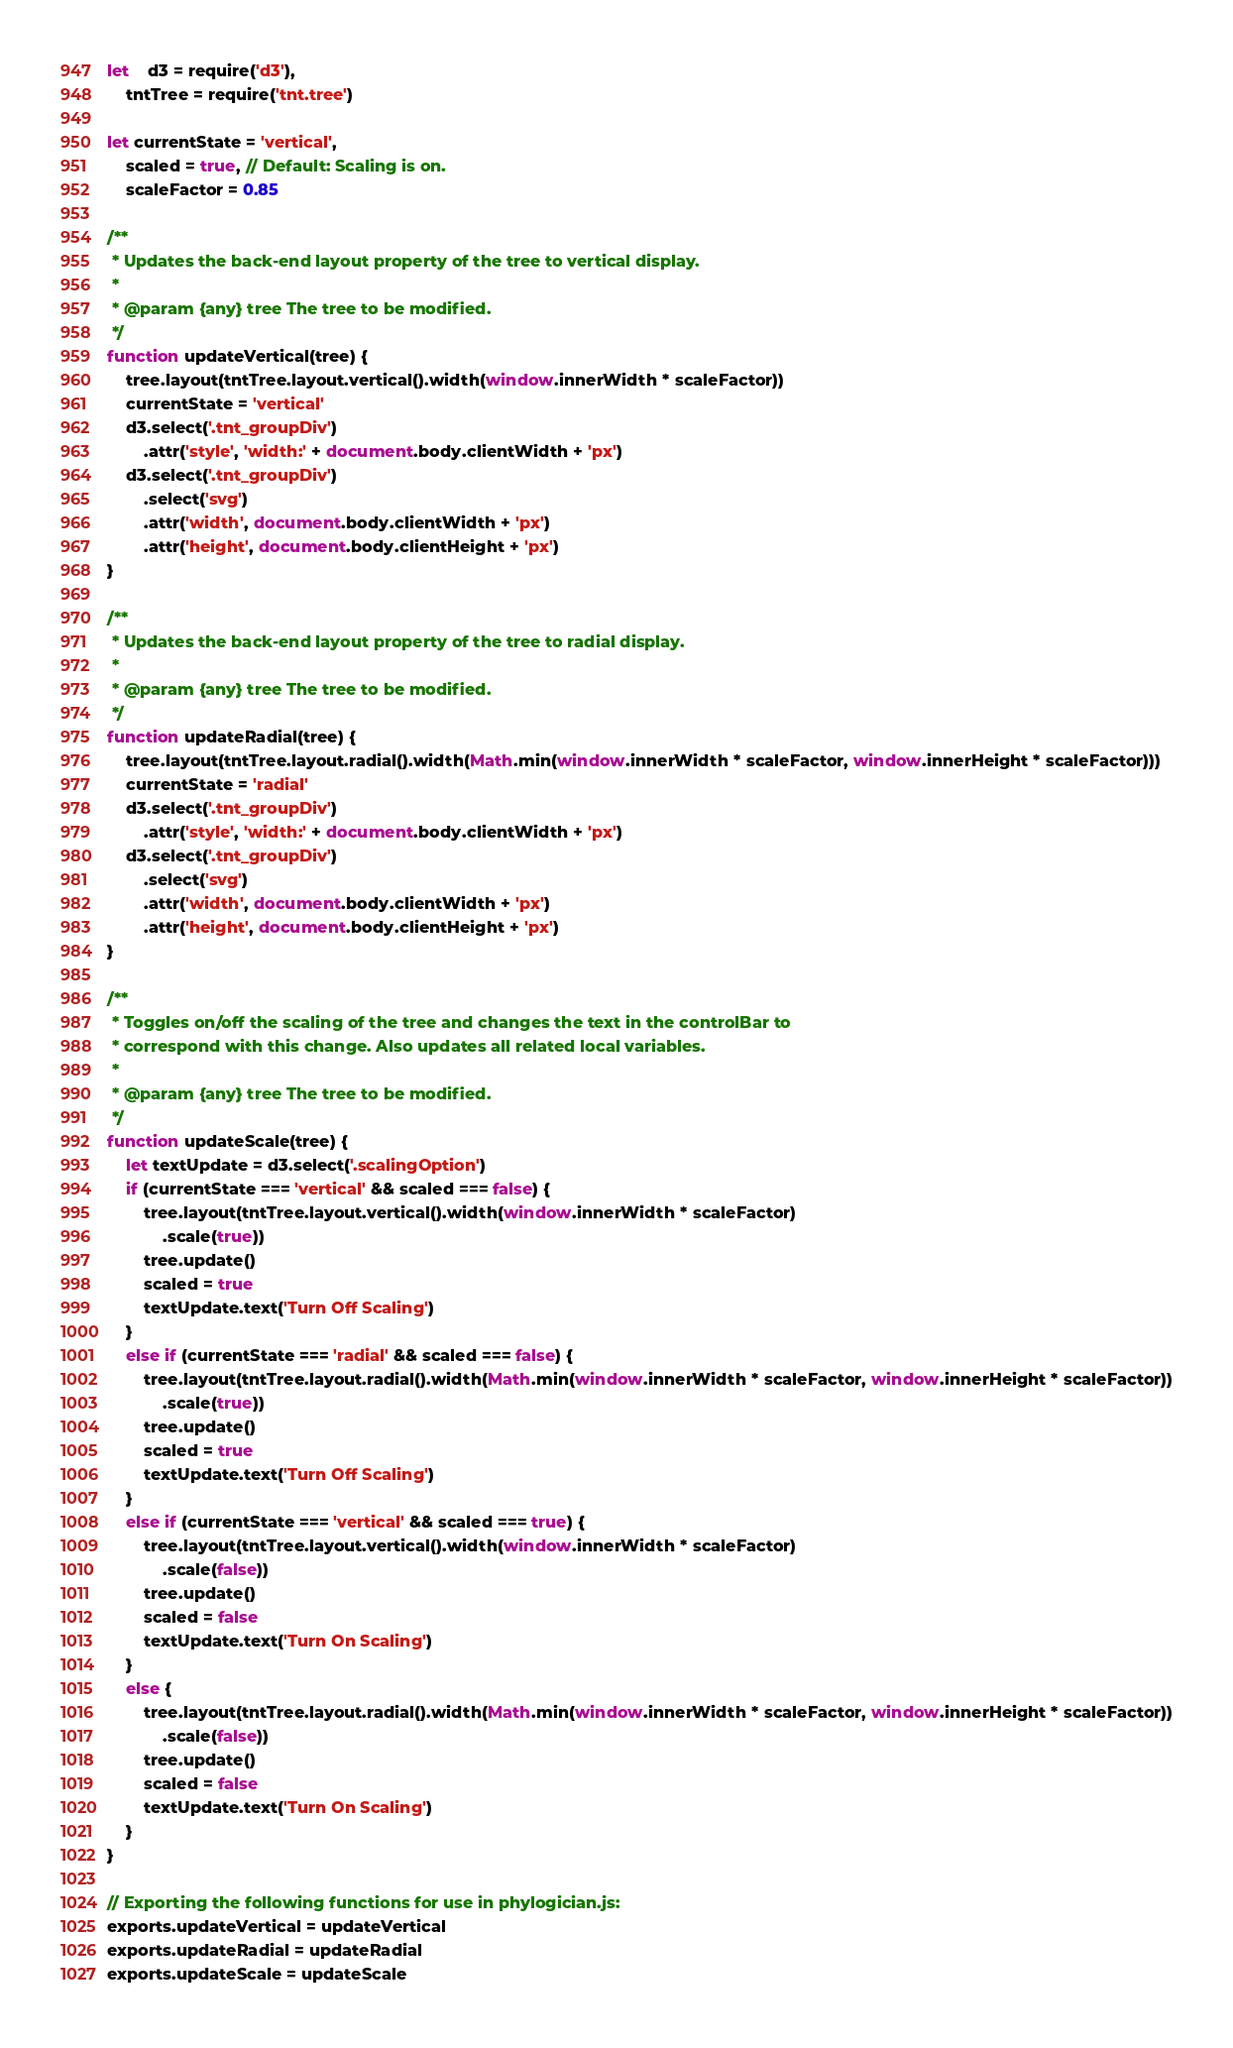<code> <loc_0><loc_0><loc_500><loc_500><_JavaScript_>
let	d3 = require('d3'),
	tntTree = require('tnt.tree')

let currentState = 'vertical',
	scaled = true, // Default: Scaling is on.
	scaleFactor = 0.85

/**
 * Updates the back-end layout property of the tree to vertical display.
 *
 * @param {any} tree The tree to be modified.
 */
function updateVertical(tree) {
	tree.layout(tntTree.layout.vertical().width(window.innerWidth * scaleFactor))
	currentState = 'vertical'
	d3.select('.tnt_groupDiv')
		.attr('style', 'width:' + document.body.clientWidth + 'px')
	d3.select('.tnt_groupDiv')
		.select('svg')
		.attr('width', document.body.clientWidth + 'px')
		.attr('height', document.body.clientHeight + 'px')
}

/**
 * Updates the back-end layout property of the tree to radial display.
 *
 * @param {any} tree The tree to be modified.
 */
function updateRadial(tree) {
	tree.layout(tntTree.layout.radial().width(Math.min(window.innerWidth * scaleFactor, window.innerHeight * scaleFactor)))
	currentState = 'radial'
	d3.select('.tnt_groupDiv')
		.attr('style', 'width:' + document.body.clientWidth + 'px')
	d3.select('.tnt_groupDiv')
		.select('svg')
		.attr('width', document.body.clientWidth + 'px')
		.attr('height', document.body.clientHeight + 'px')
}

/**
 * Toggles on/off the scaling of the tree and changes the text in the controlBar to
 * correspond with this change. Also updates all related local variables.
 *
 * @param {any} tree The tree to be modified.
 */
function updateScale(tree) {
	let textUpdate = d3.select('.scalingOption')
	if (currentState === 'vertical' && scaled === false) {
		tree.layout(tntTree.layout.vertical().width(window.innerWidth * scaleFactor)
			.scale(true))
		tree.update()
		scaled = true
		textUpdate.text('Turn Off Scaling')
	}
	else if (currentState === 'radial' && scaled === false) {
		tree.layout(tntTree.layout.radial().width(Math.min(window.innerWidth * scaleFactor, window.innerHeight * scaleFactor))
			.scale(true))
		tree.update()
		scaled = true
		textUpdate.text('Turn Off Scaling')
	}
	else if (currentState === 'vertical' && scaled === true) {
		tree.layout(tntTree.layout.vertical().width(window.innerWidth * scaleFactor)
			.scale(false))
		tree.update()
		scaled = false
		textUpdate.text('Turn On Scaling')
	}
	else {
		tree.layout(tntTree.layout.radial().width(Math.min(window.innerWidth * scaleFactor, window.innerHeight * scaleFactor))
			.scale(false))
		tree.update()
		scaled = false
		textUpdate.text('Turn On Scaling')
	}
}

// Exporting the following functions for use in phylogician.js:
exports.updateVertical = updateVertical
exports.updateRadial = updateRadial
exports.updateScale = updateScale
</code> 